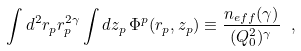<formula> <loc_0><loc_0><loc_500><loc_500>\int d ^ { 2 } r _ { p } r _ { p } ^ { 2 \gamma } \int d z _ { p } \, \Phi ^ { p } ( r _ { p } , z _ { p } ) \equiv \frac { n _ { e f f } ( \gamma ) } { ( Q _ { 0 } ^ { 2 } ) ^ { \gamma } } \ ,</formula> 